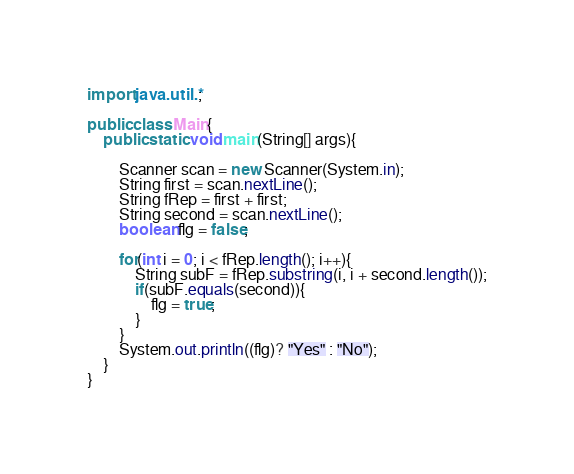<code> <loc_0><loc_0><loc_500><loc_500><_Java_>import java.util.*;

public class Main{
	public static void main(String[] args){

		Scanner scan = new Scanner(System.in);
		String first = scan.nextLine();
		String fRep = first + first;
		String second = scan.nextLine();
		boolean flg = false;

		for(int i = 0; i < fRep.length(); i++){
			String subF = fRep.substring(i, i + second.length());
			if(subF.equals(second)){
				flg = true;
			}
		}
		System.out.println((flg)? "Yes" : "No");
	}
}</code> 